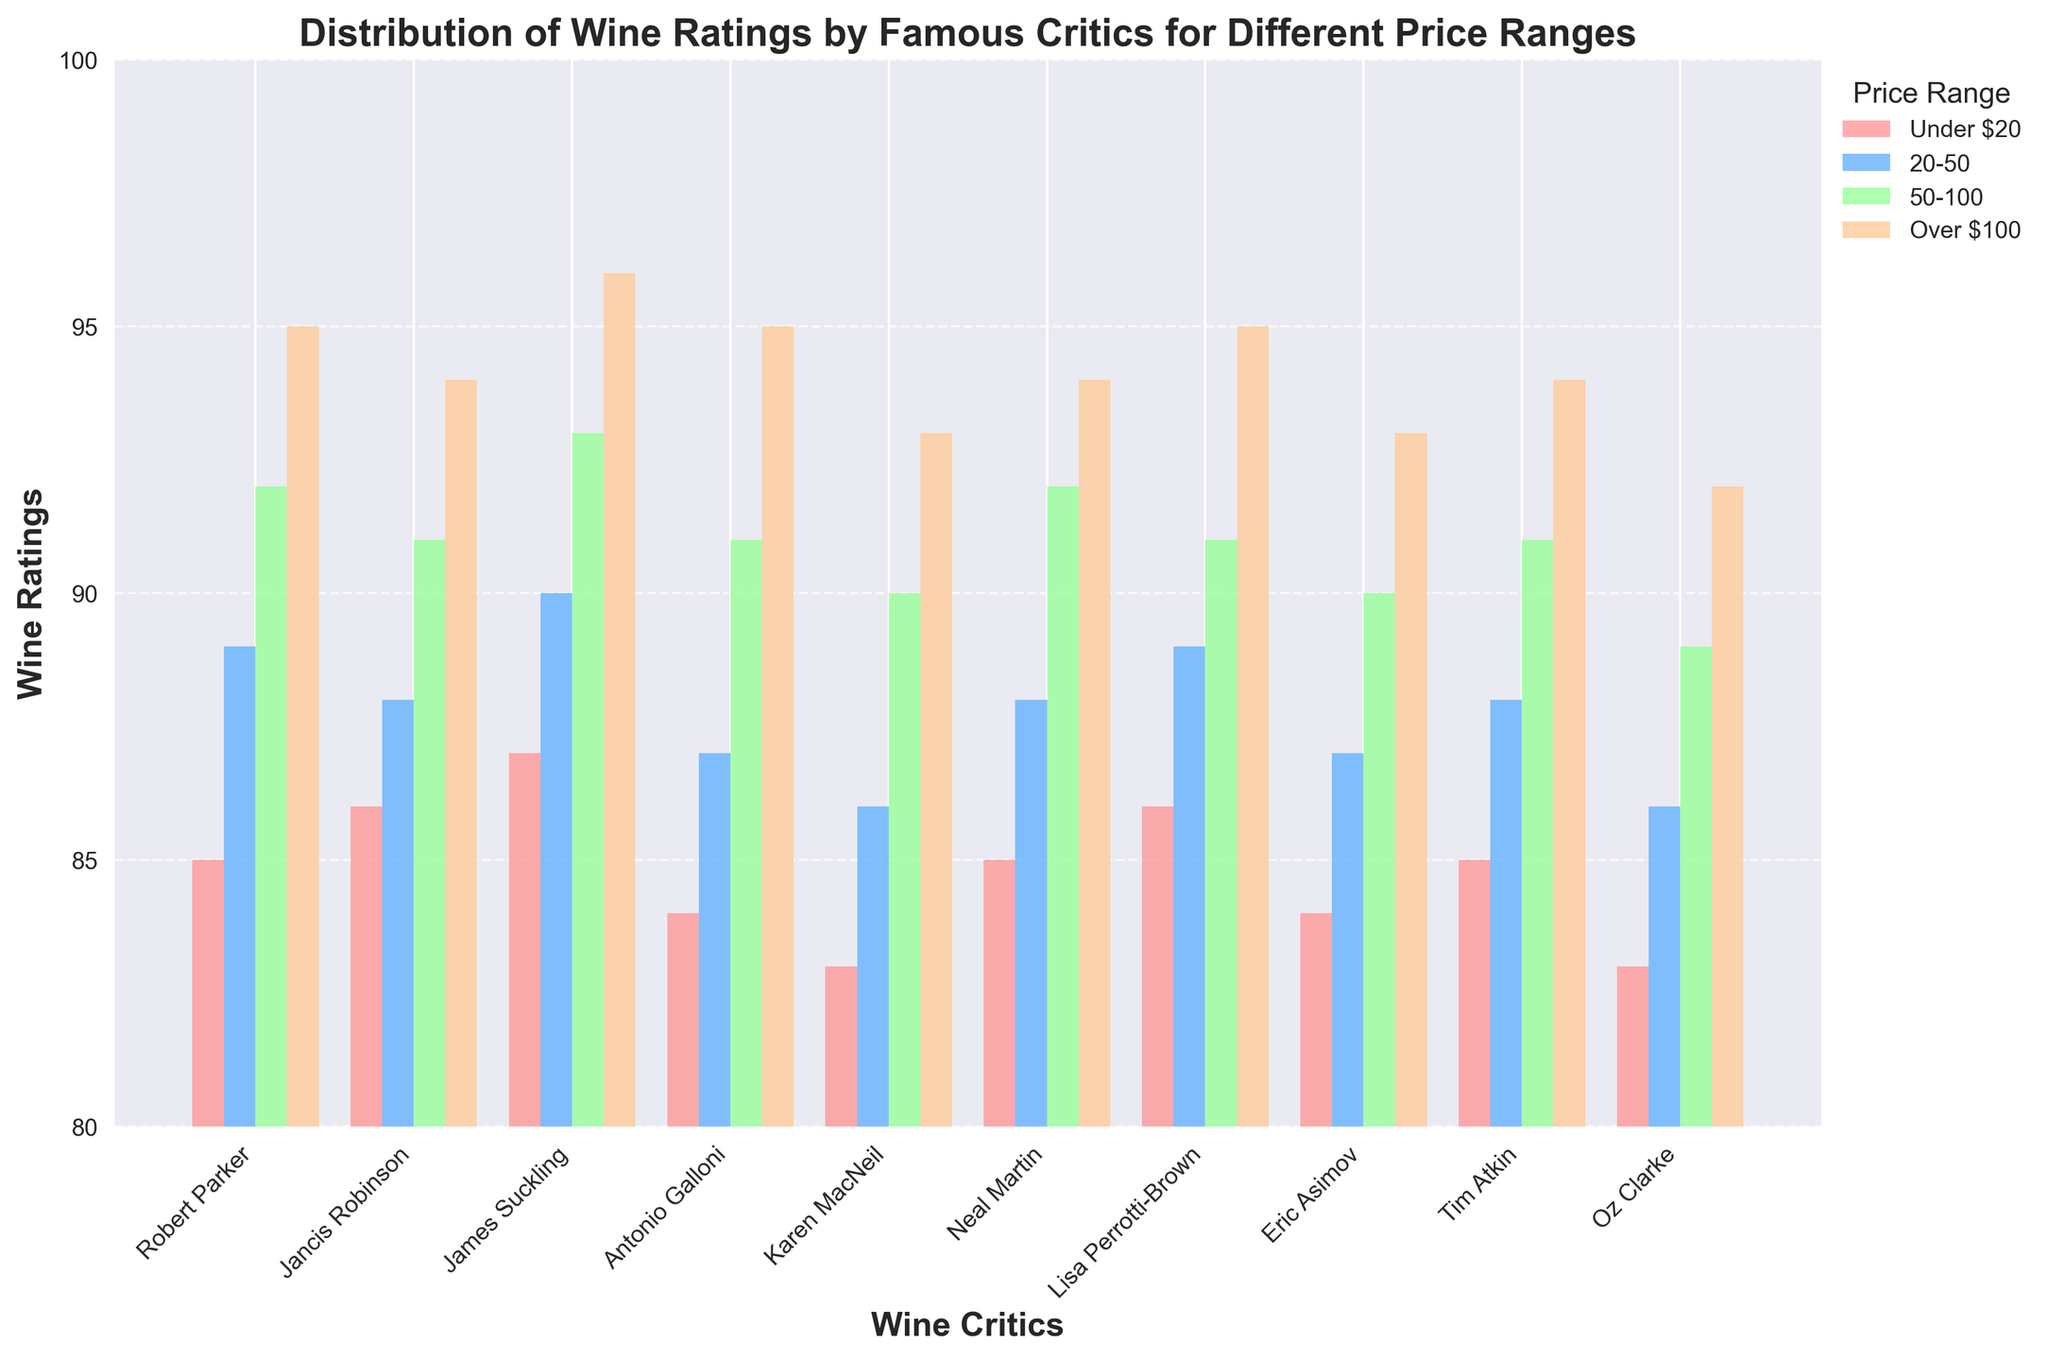Which critic gave the highest rating for wines priced between $20 and $50? To determine the highest rating in the 20-50 price range, look at the values corresponding to this range for all critics. James Suckling rated 90, which is the highest.
Answer: James Suckling What is the average rating given by Robert Parker across all price ranges? Sum Robert Parker's ratings across all price ranges (85 + 89 + 92 + 95) and divide by the number of price ranges (4). The average is (85 + 89 + 92 + 95) / 4 = 90.25.
Answer: 90.25 Which price range has the most consistent ratings across all critics? Most consistent means the least variation in ratings. Calculate the range (max - min) for each price category. Under $20 (87-83=4), 20-50 (90-86=4), 50-100 (93-89=4), Over $100 (96-92=4). The consistency is equal here, each with a range of 4.
Answer: All are equal Compare the ratings of Karen MacNeil and Neal Martin for the 'Over $100' price range and determine the difference. Find the ratings given by both critics for the 'Over $100' range: Karen MacNeil (93), Neal Martin (94). The difference is 94 - 93 = 1.
Answer: 1 For the ratings given under $20, which critics rated the wines equally? Look at the 'Under $20' ratings column, find and compare matching ratings: Robert Parker (85), Neal Martin (85) and Tim Atkin (85). Also, Jancis Robinson (86) and Lisa Perrotti-Brown (86). Oz Clarke (83) and Karen MacNeil (83).
Answer: Robert Parker, Neal Martin, Tim Atkin. Jancis Robinson, Lisa Perrotti-Brown. Oz Clarke, Karen MacNeil What is the total sum of all ratings given by Antonio Galloni? Add up Antonio Galloni's ratings across all price ranges: 84 + 87 + 91 + 95 = 357.
Answer: 357 Who rates the wines under $20 the lowest? Look at the 'Under $20' values for all critics. The lowest rating is given by Karen MacNeil and Oz Clarke at 83.
Answer: Karen MacNeil, Oz Clarke Which critic's ratings show the highest increase from the 'Under $20' to 'Over $100' price range? Calculate the difference between 'Over $100' and 'Under $20' ratings for each critic, identify the highest increase. James Suckling: 96-87=9, Robert Parker: 95-85=10, etc. Robert Parker's rating increase is 10.
Answer: Robert Parker Between which two price ranges does Eric Asimov give the largest jump in ratings? Eric Asimov's ratings are 84, 87, 90, 93 respectively. Calculate the jumps: 87-84=3, 90-87=3, 93-90=3. Each jump is 3, so no price range shows a larger jump than the others.
Answer: All ranges are equal What is the range of ratings given by Lisa Perrotti-Brown for the price range '50-100'? For the price range '50-100', note the ratings across all critics. Calculate the difference between the highest (Lisa Perrotti-Brown, 91) and lowest (Oz Clarke, 89) ratings in that range.
Answer: 2 